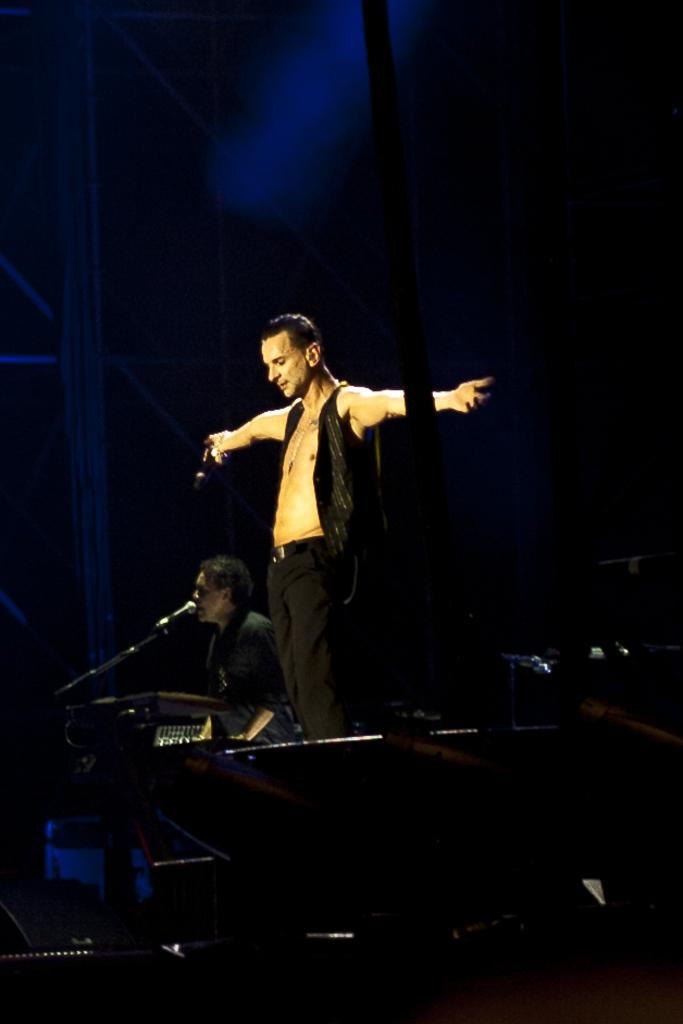What is the person on the stage doing? The person on the stage is standing. Who is beside the person on the stage? There is a person sitting beside the person on the stage. What can be seen in the image besides the people on the stage? There is a pole and a microphone with a stand in the image. What is the opinion of the river in the image? There is no river present in the image, so it is not possible to determine its opinion. 